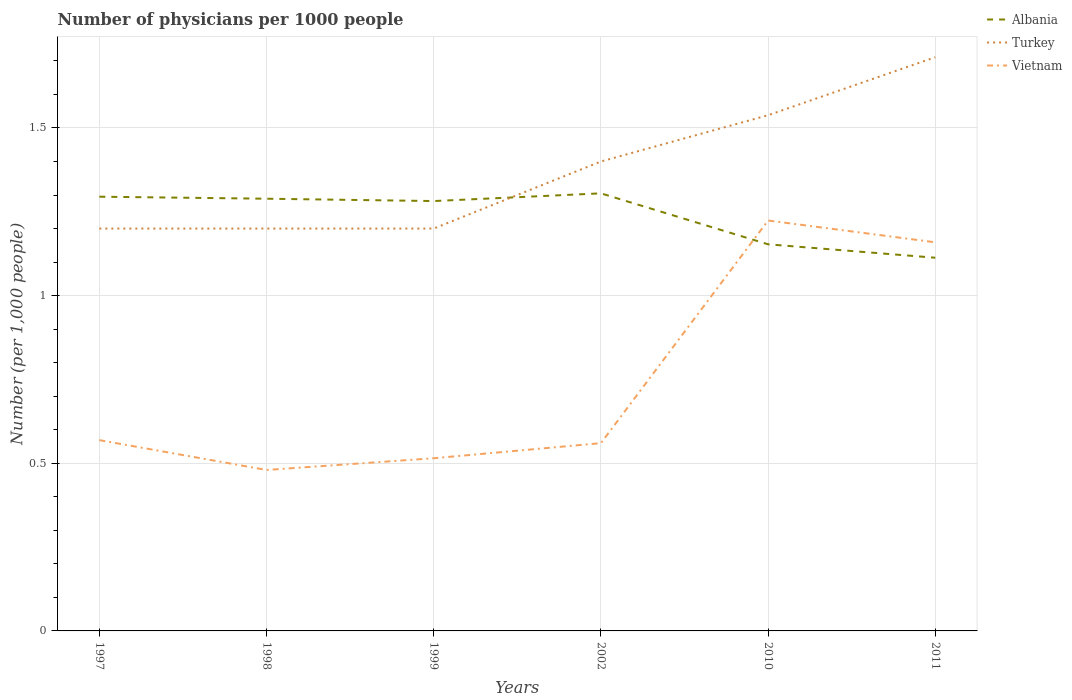How many different coloured lines are there?
Offer a very short reply. 3. Is the number of lines equal to the number of legend labels?
Offer a very short reply. Yes. Across all years, what is the maximum number of physicians in Albania?
Give a very brief answer. 1.11. In which year was the number of physicians in Albania maximum?
Your response must be concise. 2011. What is the total number of physicians in Vietnam in the graph?
Ensure brevity in your answer.  0.05. What is the difference between the highest and the second highest number of physicians in Vietnam?
Ensure brevity in your answer.  0.74. Is the number of physicians in Turkey strictly greater than the number of physicians in Vietnam over the years?
Your answer should be compact. No. How many years are there in the graph?
Offer a very short reply. 6. What is the difference between two consecutive major ticks on the Y-axis?
Your answer should be very brief. 0.5. Are the values on the major ticks of Y-axis written in scientific E-notation?
Make the answer very short. No. How many legend labels are there?
Make the answer very short. 3. What is the title of the graph?
Keep it short and to the point. Number of physicians per 1000 people. What is the label or title of the Y-axis?
Offer a very short reply. Number (per 1,0 people). What is the Number (per 1,000 people) in Albania in 1997?
Provide a succinct answer. 1.29. What is the Number (per 1,000 people) in Vietnam in 1997?
Provide a succinct answer. 0.57. What is the Number (per 1,000 people) of Albania in 1998?
Keep it short and to the point. 1.29. What is the Number (per 1,000 people) in Vietnam in 1998?
Keep it short and to the point. 0.48. What is the Number (per 1,000 people) in Albania in 1999?
Ensure brevity in your answer.  1.28. What is the Number (per 1,000 people) in Turkey in 1999?
Provide a short and direct response. 1.2. What is the Number (per 1,000 people) in Vietnam in 1999?
Make the answer very short. 0.52. What is the Number (per 1,000 people) in Albania in 2002?
Give a very brief answer. 1.3. What is the Number (per 1,000 people) in Vietnam in 2002?
Keep it short and to the point. 0.56. What is the Number (per 1,000 people) of Albania in 2010?
Give a very brief answer. 1.15. What is the Number (per 1,000 people) of Turkey in 2010?
Provide a short and direct response. 1.54. What is the Number (per 1,000 people) of Vietnam in 2010?
Provide a succinct answer. 1.22. What is the Number (per 1,000 people) in Albania in 2011?
Your answer should be very brief. 1.11. What is the Number (per 1,000 people) in Turkey in 2011?
Provide a succinct answer. 1.71. What is the Number (per 1,000 people) in Vietnam in 2011?
Your response must be concise. 1.16. Across all years, what is the maximum Number (per 1,000 people) of Albania?
Your response must be concise. 1.3. Across all years, what is the maximum Number (per 1,000 people) in Turkey?
Ensure brevity in your answer.  1.71. Across all years, what is the maximum Number (per 1,000 people) of Vietnam?
Your answer should be compact. 1.22. Across all years, what is the minimum Number (per 1,000 people) of Albania?
Make the answer very short. 1.11. Across all years, what is the minimum Number (per 1,000 people) of Turkey?
Offer a very short reply. 1.2. Across all years, what is the minimum Number (per 1,000 people) of Vietnam?
Your answer should be very brief. 0.48. What is the total Number (per 1,000 people) in Albania in the graph?
Ensure brevity in your answer.  7.44. What is the total Number (per 1,000 people) of Turkey in the graph?
Provide a short and direct response. 8.25. What is the total Number (per 1,000 people) in Vietnam in the graph?
Offer a very short reply. 4.51. What is the difference between the Number (per 1,000 people) of Albania in 1997 and that in 1998?
Make the answer very short. 0.01. What is the difference between the Number (per 1,000 people) of Vietnam in 1997 and that in 1998?
Provide a succinct answer. 0.09. What is the difference between the Number (per 1,000 people) of Albania in 1997 and that in 1999?
Keep it short and to the point. 0.01. What is the difference between the Number (per 1,000 people) in Vietnam in 1997 and that in 1999?
Your answer should be very brief. 0.05. What is the difference between the Number (per 1,000 people) in Albania in 1997 and that in 2002?
Keep it short and to the point. -0.01. What is the difference between the Number (per 1,000 people) in Turkey in 1997 and that in 2002?
Offer a very short reply. -0.2. What is the difference between the Number (per 1,000 people) of Vietnam in 1997 and that in 2002?
Provide a short and direct response. 0.01. What is the difference between the Number (per 1,000 people) in Albania in 1997 and that in 2010?
Provide a succinct answer. 0.14. What is the difference between the Number (per 1,000 people) in Turkey in 1997 and that in 2010?
Offer a very short reply. -0.34. What is the difference between the Number (per 1,000 people) of Vietnam in 1997 and that in 2010?
Keep it short and to the point. -0.66. What is the difference between the Number (per 1,000 people) of Albania in 1997 and that in 2011?
Your response must be concise. 0.18. What is the difference between the Number (per 1,000 people) of Turkey in 1997 and that in 2011?
Your response must be concise. -0.51. What is the difference between the Number (per 1,000 people) of Vietnam in 1997 and that in 2011?
Offer a terse response. -0.59. What is the difference between the Number (per 1,000 people) in Albania in 1998 and that in 1999?
Provide a short and direct response. 0.01. What is the difference between the Number (per 1,000 people) of Vietnam in 1998 and that in 1999?
Provide a succinct answer. -0.04. What is the difference between the Number (per 1,000 people) of Albania in 1998 and that in 2002?
Your answer should be very brief. -0.02. What is the difference between the Number (per 1,000 people) in Vietnam in 1998 and that in 2002?
Give a very brief answer. -0.08. What is the difference between the Number (per 1,000 people) in Albania in 1998 and that in 2010?
Provide a succinct answer. 0.14. What is the difference between the Number (per 1,000 people) in Turkey in 1998 and that in 2010?
Offer a terse response. -0.34. What is the difference between the Number (per 1,000 people) in Vietnam in 1998 and that in 2010?
Make the answer very short. -0.74. What is the difference between the Number (per 1,000 people) in Albania in 1998 and that in 2011?
Provide a short and direct response. 0.18. What is the difference between the Number (per 1,000 people) in Turkey in 1998 and that in 2011?
Make the answer very short. -0.51. What is the difference between the Number (per 1,000 people) of Vietnam in 1998 and that in 2011?
Give a very brief answer. -0.68. What is the difference between the Number (per 1,000 people) of Albania in 1999 and that in 2002?
Provide a succinct answer. -0.02. What is the difference between the Number (per 1,000 people) in Turkey in 1999 and that in 2002?
Provide a succinct answer. -0.2. What is the difference between the Number (per 1,000 people) of Vietnam in 1999 and that in 2002?
Provide a succinct answer. -0.04. What is the difference between the Number (per 1,000 people) of Albania in 1999 and that in 2010?
Offer a very short reply. 0.13. What is the difference between the Number (per 1,000 people) in Turkey in 1999 and that in 2010?
Offer a terse response. -0.34. What is the difference between the Number (per 1,000 people) of Vietnam in 1999 and that in 2010?
Your answer should be compact. -0.71. What is the difference between the Number (per 1,000 people) of Albania in 1999 and that in 2011?
Give a very brief answer. 0.17. What is the difference between the Number (per 1,000 people) of Turkey in 1999 and that in 2011?
Ensure brevity in your answer.  -0.51. What is the difference between the Number (per 1,000 people) of Vietnam in 1999 and that in 2011?
Offer a terse response. -0.64. What is the difference between the Number (per 1,000 people) of Albania in 2002 and that in 2010?
Your response must be concise. 0.15. What is the difference between the Number (per 1,000 people) of Turkey in 2002 and that in 2010?
Your answer should be very brief. -0.14. What is the difference between the Number (per 1,000 people) of Vietnam in 2002 and that in 2010?
Offer a terse response. -0.66. What is the difference between the Number (per 1,000 people) of Albania in 2002 and that in 2011?
Make the answer very short. 0.19. What is the difference between the Number (per 1,000 people) of Turkey in 2002 and that in 2011?
Make the answer very short. -0.31. What is the difference between the Number (per 1,000 people) in Vietnam in 2002 and that in 2011?
Provide a succinct answer. -0.6. What is the difference between the Number (per 1,000 people) of Turkey in 2010 and that in 2011?
Provide a succinct answer. -0.17. What is the difference between the Number (per 1,000 people) in Vietnam in 2010 and that in 2011?
Provide a short and direct response. 0.07. What is the difference between the Number (per 1,000 people) in Albania in 1997 and the Number (per 1,000 people) in Turkey in 1998?
Make the answer very short. 0.1. What is the difference between the Number (per 1,000 people) in Albania in 1997 and the Number (per 1,000 people) in Vietnam in 1998?
Offer a terse response. 0.81. What is the difference between the Number (per 1,000 people) of Turkey in 1997 and the Number (per 1,000 people) of Vietnam in 1998?
Ensure brevity in your answer.  0.72. What is the difference between the Number (per 1,000 people) in Albania in 1997 and the Number (per 1,000 people) in Turkey in 1999?
Offer a very short reply. 0.1. What is the difference between the Number (per 1,000 people) of Albania in 1997 and the Number (per 1,000 people) of Vietnam in 1999?
Keep it short and to the point. 0.78. What is the difference between the Number (per 1,000 people) of Turkey in 1997 and the Number (per 1,000 people) of Vietnam in 1999?
Give a very brief answer. 0.69. What is the difference between the Number (per 1,000 people) of Albania in 1997 and the Number (per 1,000 people) of Turkey in 2002?
Provide a short and direct response. -0.1. What is the difference between the Number (per 1,000 people) in Albania in 1997 and the Number (per 1,000 people) in Vietnam in 2002?
Offer a terse response. 0.73. What is the difference between the Number (per 1,000 people) of Turkey in 1997 and the Number (per 1,000 people) of Vietnam in 2002?
Ensure brevity in your answer.  0.64. What is the difference between the Number (per 1,000 people) of Albania in 1997 and the Number (per 1,000 people) of Turkey in 2010?
Offer a terse response. -0.24. What is the difference between the Number (per 1,000 people) in Albania in 1997 and the Number (per 1,000 people) in Vietnam in 2010?
Provide a short and direct response. 0.07. What is the difference between the Number (per 1,000 people) of Turkey in 1997 and the Number (per 1,000 people) of Vietnam in 2010?
Your answer should be compact. -0.02. What is the difference between the Number (per 1,000 people) of Albania in 1997 and the Number (per 1,000 people) of Turkey in 2011?
Ensure brevity in your answer.  -0.42. What is the difference between the Number (per 1,000 people) of Albania in 1997 and the Number (per 1,000 people) of Vietnam in 2011?
Give a very brief answer. 0.14. What is the difference between the Number (per 1,000 people) of Turkey in 1997 and the Number (per 1,000 people) of Vietnam in 2011?
Make the answer very short. 0.04. What is the difference between the Number (per 1,000 people) of Albania in 1998 and the Number (per 1,000 people) of Turkey in 1999?
Give a very brief answer. 0.09. What is the difference between the Number (per 1,000 people) of Albania in 1998 and the Number (per 1,000 people) of Vietnam in 1999?
Offer a terse response. 0.77. What is the difference between the Number (per 1,000 people) of Turkey in 1998 and the Number (per 1,000 people) of Vietnam in 1999?
Offer a very short reply. 0.69. What is the difference between the Number (per 1,000 people) in Albania in 1998 and the Number (per 1,000 people) in Turkey in 2002?
Make the answer very short. -0.11. What is the difference between the Number (per 1,000 people) in Albania in 1998 and the Number (per 1,000 people) in Vietnam in 2002?
Make the answer very short. 0.73. What is the difference between the Number (per 1,000 people) of Turkey in 1998 and the Number (per 1,000 people) of Vietnam in 2002?
Your answer should be compact. 0.64. What is the difference between the Number (per 1,000 people) of Albania in 1998 and the Number (per 1,000 people) of Turkey in 2010?
Your response must be concise. -0.25. What is the difference between the Number (per 1,000 people) in Albania in 1998 and the Number (per 1,000 people) in Vietnam in 2010?
Offer a terse response. 0.07. What is the difference between the Number (per 1,000 people) in Turkey in 1998 and the Number (per 1,000 people) in Vietnam in 2010?
Keep it short and to the point. -0.02. What is the difference between the Number (per 1,000 people) of Albania in 1998 and the Number (per 1,000 people) of Turkey in 2011?
Your answer should be compact. -0.42. What is the difference between the Number (per 1,000 people) in Albania in 1998 and the Number (per 1,000 people) in Vietnam in 2011?
Your answer should be very brief. 0.13. What is the difference between the Number (per 1,000 people) of Turkey in 1998 and the Number (per 1,000 people) of Vietnam in 2011?
Your answer should be very brief. 0.04. What is the difference between the Number (per 1,000 people) in Albania in 1999 and the Number (per 1,000 people) in Turkey in 2002?
Offer a very short reply. -0.12. What is the difference between the Number (per 1,000 people) in Albania in 1999 and the Number (per 1,000 people) in Vietnam in 2002?
Your answer should be compact. 0.72. What is the difference between the Number (per 1,000 people) in Turkey in 1999 and the Number (per 1,000 people) in Vietnam in 2002?
Provide a short and direct response. 0.64. What is the difference between the Number (per 1,000 people) in Albania in 1999 and the Number (per 1,000 people) in Turkey in 2010?
Ensure brevity in your answer.  -0.26. What is the difference between the Number (per 1,000 people) of Albania in 1999 and the Number (per 1,000 people) of Vietnam in 2010?
Provide a succinct answer. 0.06. What is the difference between the Number (per 1,000 people) in Turkey in 1999 and the Number (per 1,000 people) in Vietnam in 2010?
Offer a very short reply. -0.02. What is the difference between the Number (per 1,000 people) in Albania in 1999 and the Number (per 1,000 people) in Turkey in 2011?
Keep it short and to the point. -0.43. What is the difference between the Number (per 1,000 people) of Albania in 1999 and the Number (per 1,000 people) of Vietnam in 2011?
Your answer should be compact. 0.12. What is the difference between the Number (per 1,000 people) in Turkey in 1999 and the Number (per 1,000 people) in Vietnam in 2011?
Your response must be concise. 0.04. What is the difference between the Number (per 1,000 people) of Albania in 2002 and the Number (per 1,000 people) of Turkey in 2010?
Give a very brief answer. -0.23. What is the difference between the Number (per 1,000 people) in Albania in 2002 and the Number (per 1,000 people) in Vietnam in 2010?
Provide a succinct answer. 0.08. What is the difference between the Number (per 1,000 people) of Turkey in 2002 and the Number (per 1,000 people) of Vietnam in 2010?
Your answer should be very brief. 0.18. What is the difference between the Number (per 1,000 people) of Albania in 2002 and the Number (per 1,000 people) of Turkey in 2011?
Offer a terse response. -0.41. What is the difference between the Number (per 1,000 people) of Albania in 2002 and the Number (per 1,000 people) of Vietnam in 2011?
Give a very brief answer. 0.15. What is the difference between the Number (per 1,000 people) of Turkey in 2002 and the Number (per 1,000 people) of Vietnam in 2011?
Provide a short and direct response. 0.24. What is the difference between the Number (per 1,000 people) of Albania in 2010 and the Number (per 1,000 people) of Turkey in 2011?
Give a very brief answer. -0.56. What is the difference between the Number (per 1,000 people) of Albania in 2010 and the Number (per 1,000 people) of Vietnam in 2011?
Provide a succinct answer. -0.01. What is the difference between the Number (per 1,000 people) in Turkey in 2010 and the Number (per 1,000 people) in Vietnam in 2011?
Provide a succinct answer. 0.38. What is the average Number (per 1,000 people) of Albania per year?
Provide a succinct answer. 1.24. What is the average Number (per 1,000 people) of Turkey per year?
Your answer should be compact. 1.37. What is the average Number (per 1,000 people) in Vietnam per year?
Provide a short and direct response. 0.75. In the year 1997, what is the difference between the Number (per 1,000 people) in Albania and Number (per 1,000 people) in Turkey?
Offer a terse response. 0.1. In the year 1997, what is the difference between the Number (per 1,000 people) of Albania and Number (per 1,000 people) of Vietnam?
Offer a terse response. 0.73. In the year 1997, what is the difference between the Number (per 1,000 people) of Turkey and Number (per 1,000 people) of Vietnam?
Your answer should be very brief. 0.63. In the year 1998, what is the difference between the Number (per 1,000 people) in Albania and Number (per 1,000 people) in Turkey?
Your answer should be compact. 0.09. In the year 1998, what is the difference between the Number (per 1,000 people) in Albania and Number (per 1,000 people) in Vietnam?
Your answer should be very brief. 0.81. In the year 1998, what is the difference between the Number (per 1,000 people) in Turkey and Number (per 1,000 people) in Vietnam?
Offer a terse response. 0.72. In the year 1999, what is the difference between the Number (per 1,000 people) in Albania and Number (per 1,000 people) in Turkey?
Offer a very short reply. 0.08. In the year 1999, what is the difference between the Number (per 1,000 people) of Albania and Number (per 1,000 people) of Vietnam?
Provide a succinct answer. 0.77. In the year 1999, what is the difference between the Number (per 1,000 people) in Turkey and Number (per 1,000 people) in Vietnam?
Your answer should be very brief. 0.69. In the year 2002, what is the difference between the Number (per 1,000 people) of Albania and Number (per 1,000 people) of Turkey?
Provide a short and direct response. -0.1. In the year 2002, what is the difference between the Number (per 1,000 people) of Albania and Number (per 1,000 people) of Vietnam?
Provide a succinct answer. 0.74. In the year 2002, what is the difference between the Number (per 1,000 people) of Turkey and Number (per 1,000 people) of Vietnam?
Offer a very short reply. 0.84. In the year 2010, what is the difference between the Number (per 1,000 people) of Albania and Number (per 1,000 people) of Turkey?
Offer a terse response. -0.39. In the year 2010, what is the difference between the Number (per 1,000 people) of Albania and Number (per 1,000 people) of Vietnam?
Your answer should be very brief. -0.07. In the year 2010, what is the difference between the Number (per 1,000 people) of Turkey and Number (per 1,000 people) of Vietnam?
Ensure brevity in your answer.  0.31. In the year 2011, what is the difference between the Number (per 1,000 people) in Albania and Number (per 1,000 people) in Turkey?
Provide a succinct answer. -0.6. In the year 2011, what is the difference between the Number (per 1,000 people) of Albania and Number (per 1,000 people) of Vietnam?
Offer a very short reply. -0.05. In the year 2011, what is the difference between the Number (per 1,000 people) in Turkey and Number (per 1,000 people) in Vietnam?
Keep it short and to the point. 0.55. What is the ratio of the Number (per 1,000 people) of Vietnam in 1997 to that in 1998?
Offer a terse response. 1.19. What is the ratio of the Number (per 1,000 people) in Vietnam in 1997 to that in 1999?
Your answer should be very brief. 1.1. What is the ratio of the Number (per 1,000 people) in Albania in 1997 to that in 2002?
Make the answer very short. 0.99. What is the ratio of the Number (per 1,000 people) of Vietnam in 1997 to that in 2002?
Make the answer very short. 1.02. What is the ratio of the Number (per 1,000 people) of Albania in 1997 to that in 2010?
Ensure brevity in your answer.  1.12. What is the ratio of the Number (per 1,000 people) in Turkey in 1997 to that in 2010?
Provide a succinct answer. 0.78. What is the ratio of the Number (per 1,000 people) of Vietnam in 1997 to that in 2010?
Your answer should be compact. 0.46. What is the ratio of the Number (per 1,000 people) in Albania in 1997 to that in 2011?
Keep it short and to the point. 1.16. What is the ratio of the Number (per 1,000 people) of Turkey in 1997 to that in 2011?
Keep it short and to the point. 0.7. What is the ratio of the Number (per 1,000 people) in Vietnam in 1997 to that in 2011?
Your answer should be compact. 0.49. What is the ratio of the Number (per 1,000 people) in Turkey in 1998 to that in 1999?
Your answer should be compact. 1. What is the ratio of the Number (per 1,000 people) in Vietnam in 1998 to that in 1999?
Your answer should be compact. 0.93. What is the ratio of the Number (per 1,000 people) in Turkey in 1998 to that in 2002?
Give a very brief answer. 0.86. What is the ratio of the Number (per 1,000 people) of Vietnam in 1998 to that in 2002?
Keep it short and to the point. 0.86. What is the ratio of the Number (per 1,000 people) of Albania in 1998 to that in 2010?
Your answer should be compact. 1.12. What is the ratio of the Number (per 1,000 people) in Turkey in 1998 to that in 2010?
Offer a very short reply. 0.78. What is the ratio of the Number (per 1,000 people) of Vietnam in 1998 to that in 2010?
Provide a short and direct response. 0.39. What is the ratio of the Number (per 1,000 people) of Albania in 1998 to that in 2011?
Keep it short and to the point. 1.16. What is the ratio of the Number (per 1,000 people) in Turkey in 1998 to that in 2011?
Offer a very short reply. 0.7. What is the ratio of the Number (per 1,000 people) in Vietnam in 1998 to that in 2011?
Your response must be concise. 0.41. What is the ratio of the Number (per 1,000 people) in Albania in 1999 to that in 2002?
Your response must be concise. 0.98. What is the ratio of the Number (per 1,000 people) of Vietnam in 1999 to that in 2002?
Keep it short and to the point. 0.92. What is the ratio of the Number (per 1,000 people) in Albania in 1999 to that in 2010?
Make the answer very short. 1.11. What is the ratio of the Number (per 1,000 people) of Turkey in 1999 to that in 2010?
Give a very brief answer. 0.78. What is the ratio of the Number (per 1,000 people) of Vietnam in 1999 to that in 2010?
Offer a very short reply. 0.42. What is the ratio of the Number (per 1,000 people) of Albania in 1999 to that in 2011?
Offer a terse response. 1.15. What is the ratio of the Number (per 1,000 people) in Turkey in 1999 to that in 2011?
Ensure brevity in your answer.  0.7. What is the ratio of the Number (per 1,000 people) of Vietnam in 1999 to that in 2011?
Provide a succinct answer. 0.44. What is the ratio of the Number (per 1,000 people) in Albania in 2002 to that in 2010?
Provide a short and direct response. 1.13. What is the ratio of the Number (per 1,000 people) of Turkey in 2002 to that in 2010?
Ensure brevity in your answer.  0.91. What is the ratio of the Number (per 1,000 people) in Vietnam in 2002 to that in 2010?
Offer a very short reply. 0.46. What is the ratio of the Number (per 1,000 people) of Albania in 2002 to that in 2011?
Offer a terse response. 1.17. What is the ratio of the Number (per 1,000 people) in Turkey in 2002 to that in 2011?
Your answer should be compact. 0.82. What is the ratio of the Number (per 1,000 people) in Vietnam in 2002 to that in 2011?
Your answer should be compact. 0.48. What is the ratio of the Number (per 1,000 people) of Albania in 2010 to that in 2011?
Your answer should be very brief. 1.04. What is the ratio of the Number (per 1,000 people) of Turkey in 2010 to that in 2011?
Give a very brief answer. 0.9. What is the ratio of the Number (per 1,000 people) in Vietnam in 2010 to that in 2011?
Give a very brief answer. 1.06. What is the difference between the highest and the second highest Number (per 1,000 people) in Albania?
Offer a terse response. 0.01. What is the difference between the highest and the second highest Number (per 1,000 people) of Turkey?
Ensure brevity in your answer.  0.17. What is the difference between the highest and the second highest Number (per 1,000 people) in Vietnam?
Your answer should be very brief. 0.07. What is the difference between the highest and the lowest Number (per 1,000 people) of Albania?
Ensure brevity in your answer.  0.19. What is the difference between the highest and the lowest Number (per 1,000 people) in Turkey?
Your answer should be compact. 0.51. What is the difference between the highest and the lowest Number (per 1,000 people) in Vietnam?
Your response must be concise. 0.74. 